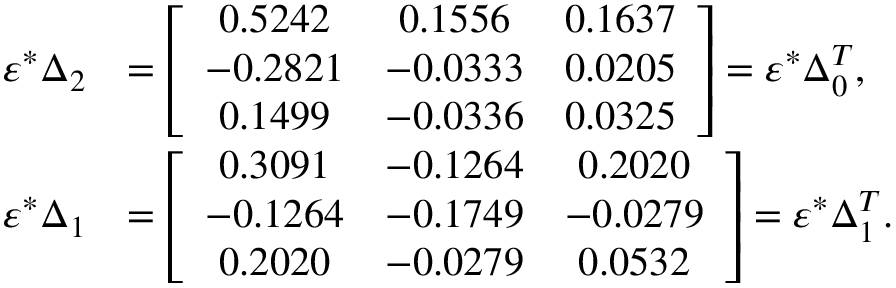<formula> <loc_0><loc_0><loc_500><loc_500>\begin{array} { r l } { \varepsilon ^ { * } \Delta _ { 2 } } & { = \left [ \begin{array} { c c c } { 0 . 5 2 4 2 } & { 0 . 1 5 5 6 } & { 0 . 1 6 3 7 } \\ { - 0 . 2 8 2 1 } & { - 0 . 0 3 3 3 } & { 0 . 0 2 0 5 } \\ { 0 . 1 4 9 9 } & { - 0 . 0 3 3 6 } & { 0 . 0 3 2 5 } \end{array} \right ] = \varepsilon ^ { * } \Delta _ { 0 } ^ { T } , } \\ { \varepsilon ^ { * } \Delta _ { 1 } } & { = \left [ \begin{array} { c c c } { 0 . 3 0 9 1 } & { - 0 . 1 2 6 4 } & { 0 . 2 0 2 0 } \\ { - 0 . 1 2 6 4 } & { - 0 . 1 7 4 9 } & { - 0 . 0 2 7 9 } \\ { 0 . 2 0 2 0 } & { - 0 . 0 2 7 9 } & { 0 . 0 5 3 2 } \end{array} \right ] = \varepsilon ^ { * } \Delta _ { 1 } ^ { T } . } \end{array}</formula> 